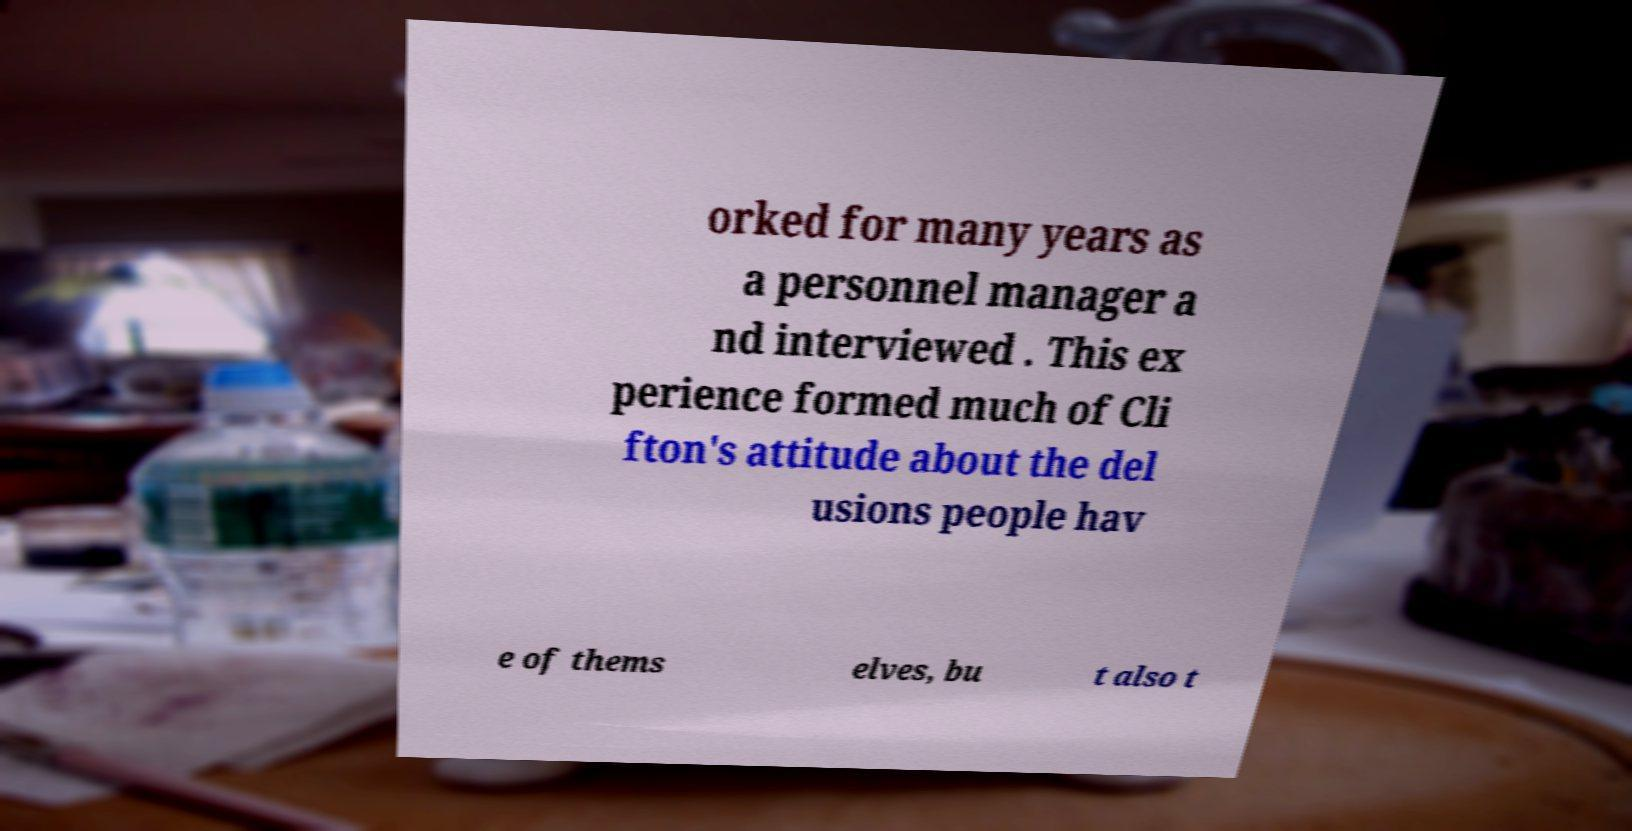Please read and relay the text visible in this image. What does it say? orked for many years as a personnel manager a nd interviewed . This ex perience formed much of Cli fton's attitude about the del usions people hav e of thems elves, bu t also t 